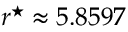Convert formula to latex. <formula><loc_0><loc_0><loc_500><loc_500>r ^ { ^ { * } } \approx 5 . 8 5 9 7</formula> 